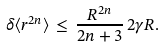<formula> <loc_0><loc_0><loc_500><loc_500>\delta \langle r ^ { 2 n } \rangle \, \leq \, \frac { R ^ { 2 n } } { 2 n + 3 } \, 2 \gamma R .</formula> 